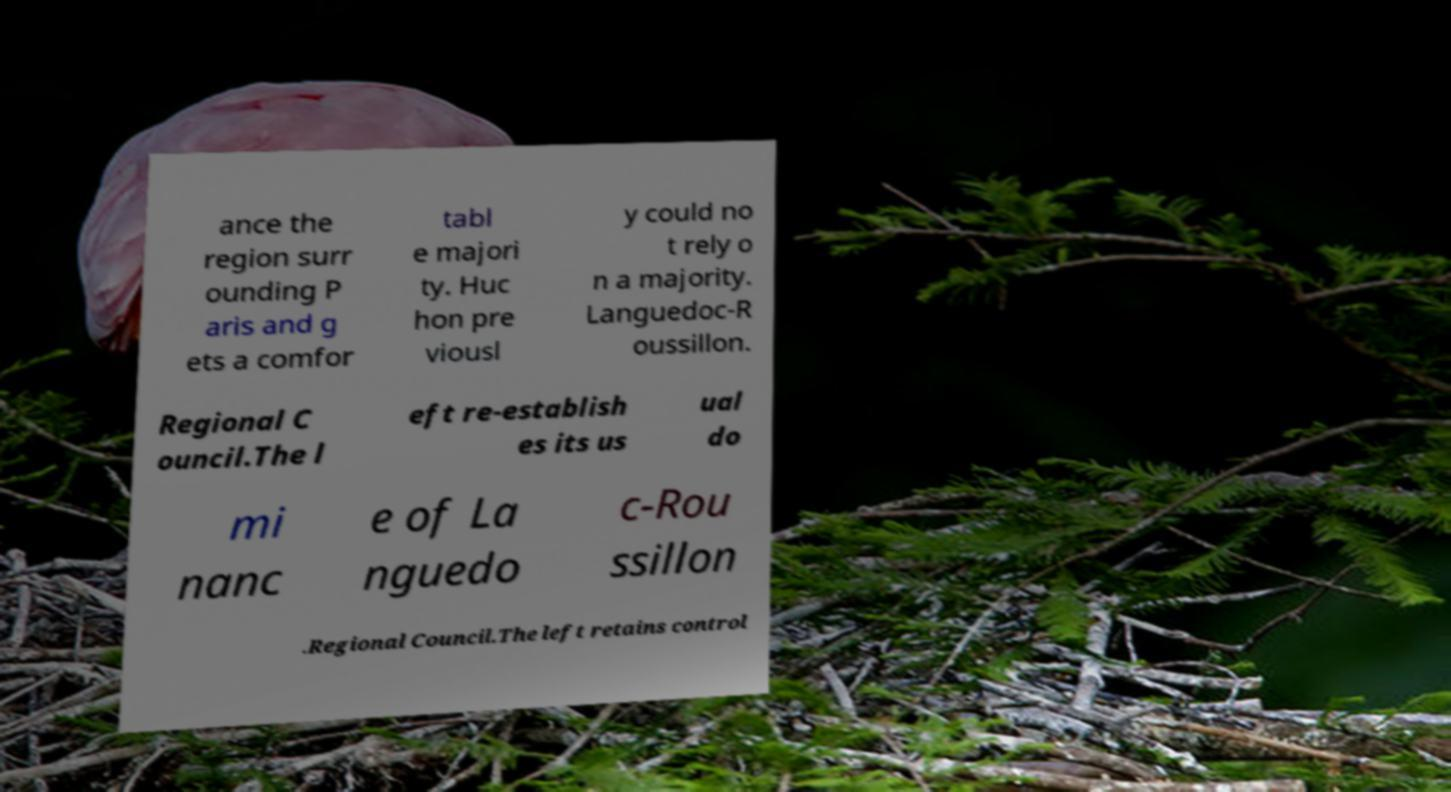Can you read and provide the text displayed in the image?This photo seems to have some interesting text. Can you extract and type it out for me? ance the region surr ounding P aris and g ets a comfor tabl e majori ty. Huc hon pre viousl y could no t rely o n a majority. Languedoc-R oussillon. Regional C ouncil.The l eft re-establish es its us ual do mi nanc e of La nguedo c-Rou ssillon .Regional Council.The left retains control 